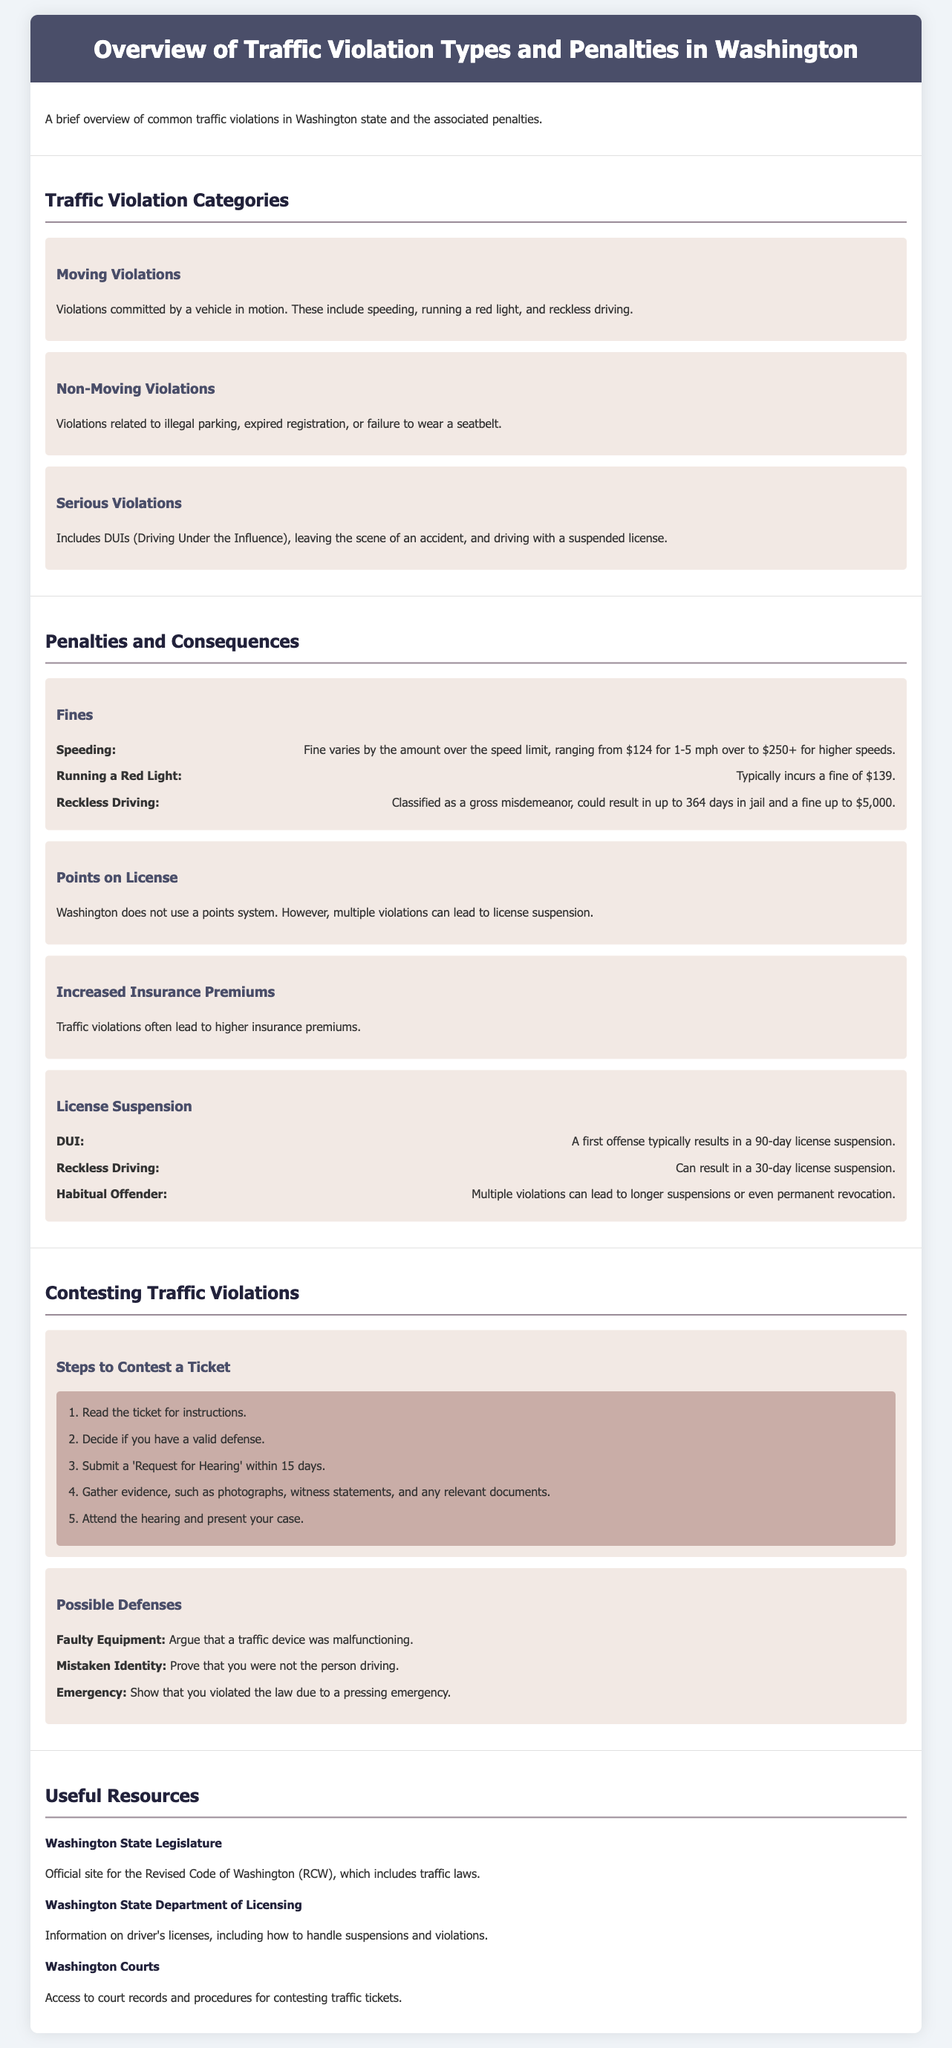What is a common moving violation? This information is found in the section detailing traffic violation categories, specifically under moving violations.
Answer: Speeding What is the fine for running a red light? The fine is specified under the penalties and consequences section.
Answer: $139 What is the potential jail time for reckless driving? This detail is found in the penalties section, providing insight into the consequences of this specific violation.
Answer: Up to 364 days How many days is a first DUI offense license suspension? This information is located in the license suspension subsection mentioned under penalties.
Answer: 90 days What is the first step to contest a traffic ticket? The first step is outlined in the steps to contest a ticket section in the document.
Answer: Read the ticket for instructions What is the penalty for habitual offenders? This information can be found under the license suspension section, specifically related to habitual offenses.
Answer: Longer suspensions or even permanent revocation What type of violation is driving with a suspended license classified as? This classification can be found within the serious violations subsection.
Answer: Serious Violation Which department provides information on driver's licenses? This information is found under the useful resources section specifically for government services.
Answer: Washington State Department of Licensing 